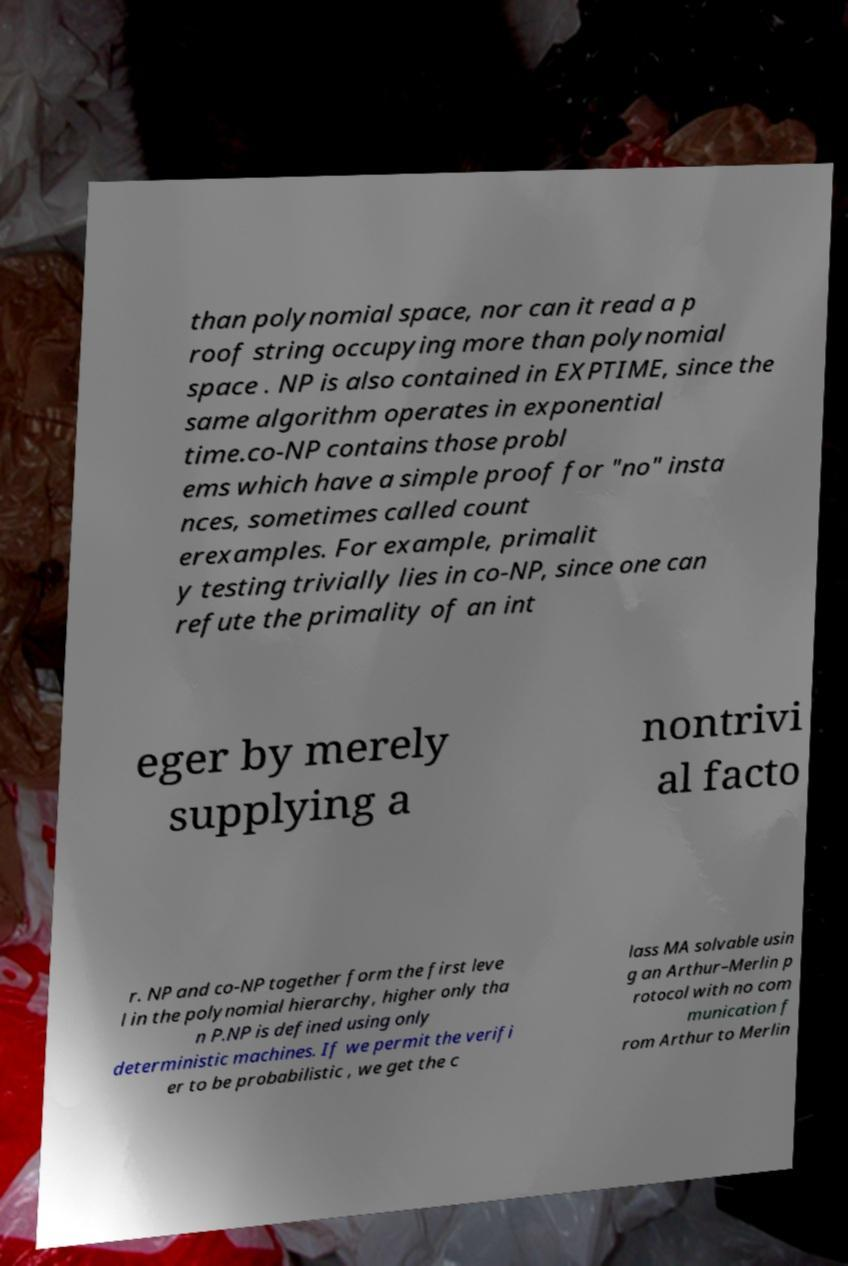Please read and relay the text visible in this image. What does it say? than polynomial space, nor can it read a p roof string occupying more than polynomial space . NP is also contained in EXPTIME, since the same algorithm operates in exponential time.co-NP contains those probl ems which have a simple proof for "no" insta nces, sometimes called count erexamples. For example, primalit y testing trivially lies in co-NP, since one can refute the primality of an int eger by merely supplying a nontrivi al facto r. NP and co-NP together form the first leve l in the polynomial hierarchy, higher only tha n P.NP is defined using only deterministic machines. If we permit the verifi er to be probabilistic , we get the c lass MA solvable usin g an Arthur–Merlin p rotocol with no com munication f rom Arthur to Merlin 